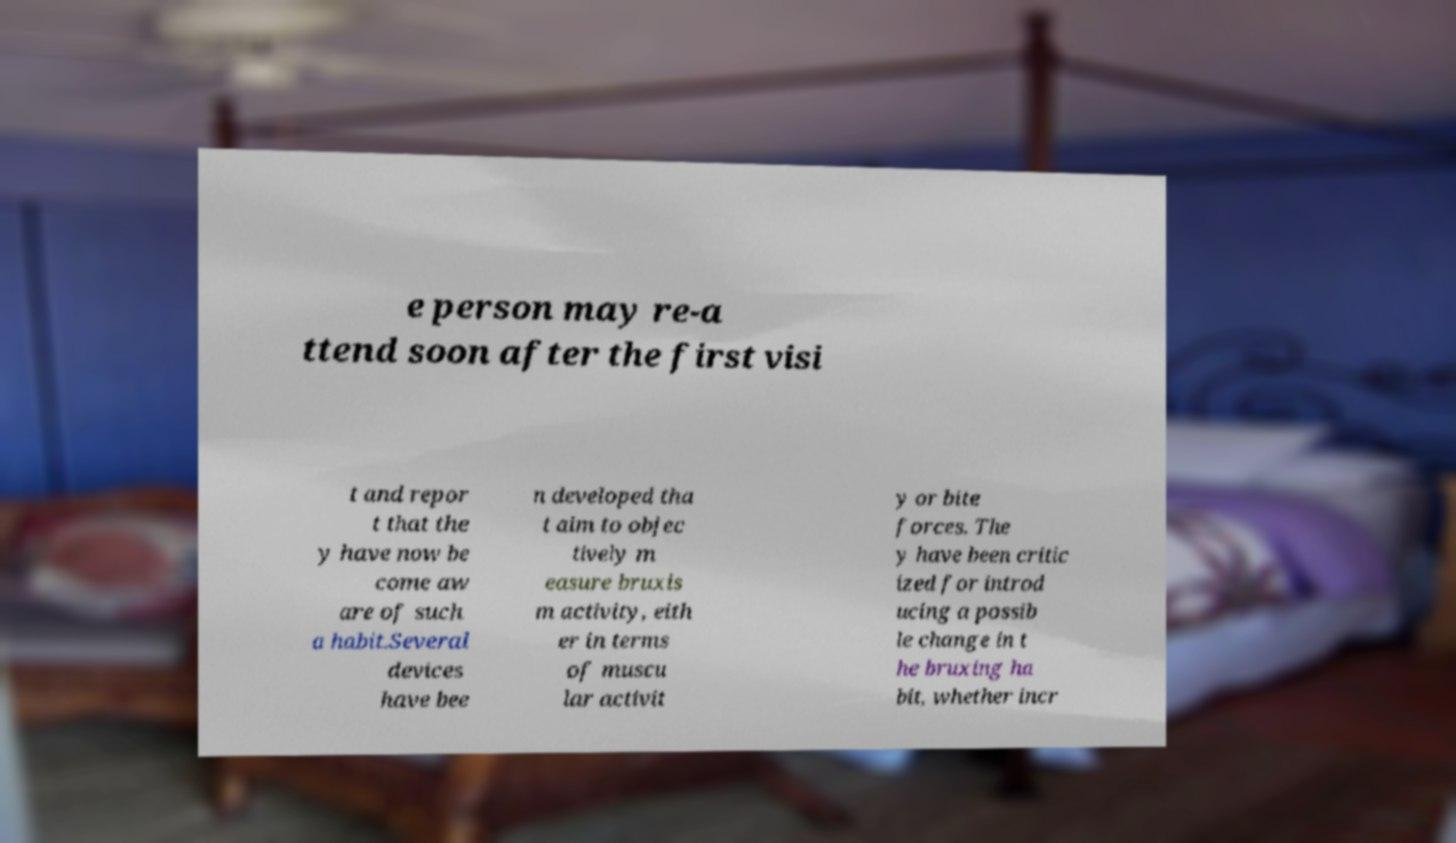Could you assist in decoding the text presented in this image and type it out clearly? e person may re-a ttend soon after the first visi t and repor t that the y have now be come aw are of such a habit.Several devices have bee n developed tha t aim to objec tively m easure bruxis m activity, eith er in terms of muscu lar activit y or bite forces. The y have been critic ized for introd ucing a possib le change in t he bruxing ha bit, whether incr 